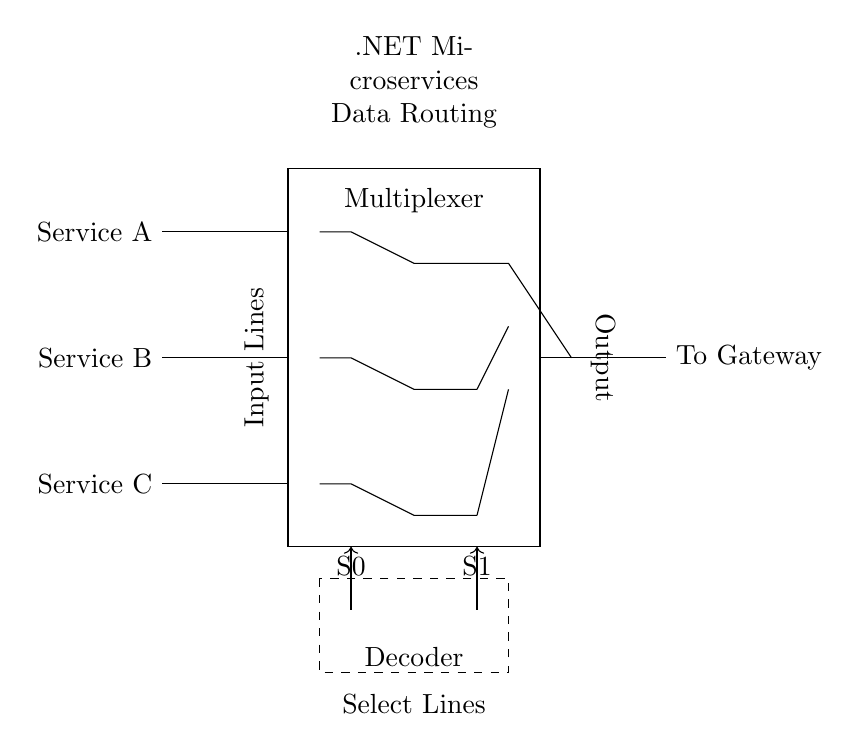What are the input services for this multiplexer? The input services are Service A, Service B, and Service C, which are connected to the input lines of the multiplexer as labeled in the diagram.
Answer: Service A, Service B, Service C What do the select lines control in this circuit? The select lines S0 and S1 determine which of the input services (A, B, or C) to route to the output. The combination of the states of these lines selects the corresponding data input based on their values.
Answer: Data routing What is the function of the OR gate in this circuit? The OR gate combines the outputs from the AND gates, which process the selected input signals based on the select line values, allowing the appropriate service data to pass through to the output.
Answer: Combine output How many AND gates are in this multiplexer? There are three AND gates, each responsible for enabling the path of one of the three input services based on the select lines' status.
Answer: Three Which component specifies the output to the gateway? The output is routed to the Gateway via the OR gate, which collects the outputs from the AND gates and directs the selected service to the designated output line.
Answer: OR gate What is the purpose of the decoder in this circuit? The decoder interprets the binary values of the select lines S0 and S1, generating the necessary control signals to activate the appropriate AND gate for routing specific service data to the output.
Answer: Control signals What overall function does this circuit serve in a microservices architecture? The circuit serves to route data from various services selectively, which is essential for managing which service provides data to the gateway, ensuring efficient communication in a microservices architecture.
Answer: Data routing 